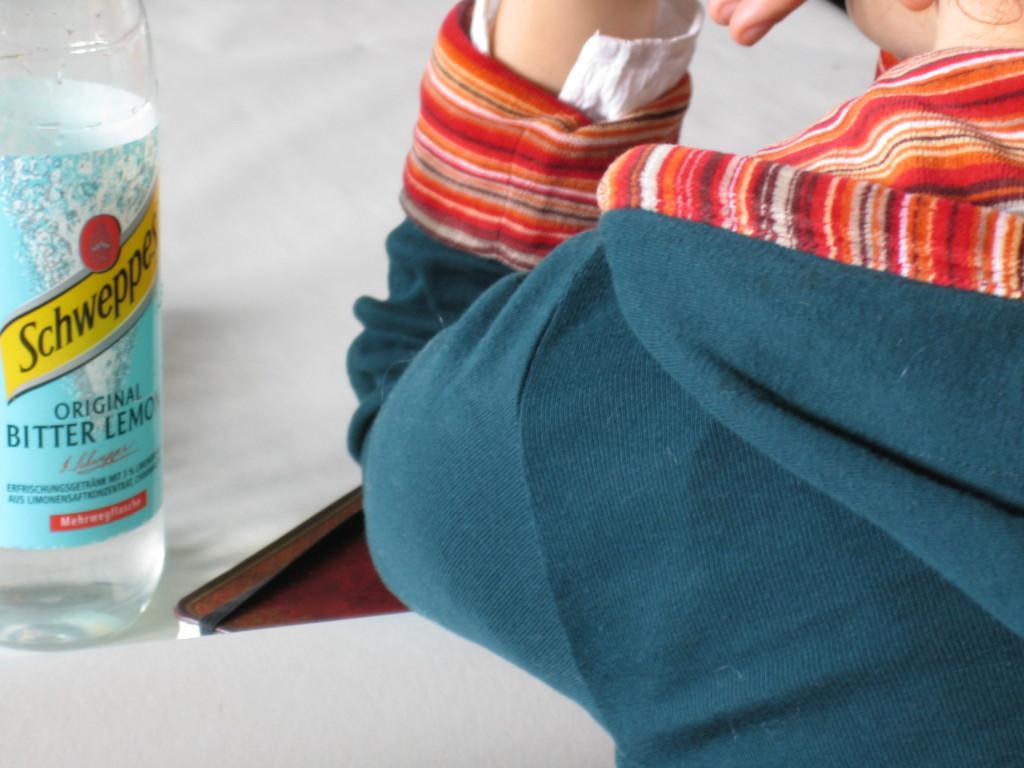Could you give a brief overview of what you see in this image? There is a person in the image in which wearing a blue color shirt and on the left side we can see a water bottle in which it is labelled as ORIGINAL BITTER LEMON. On the bottom we can see a book. 